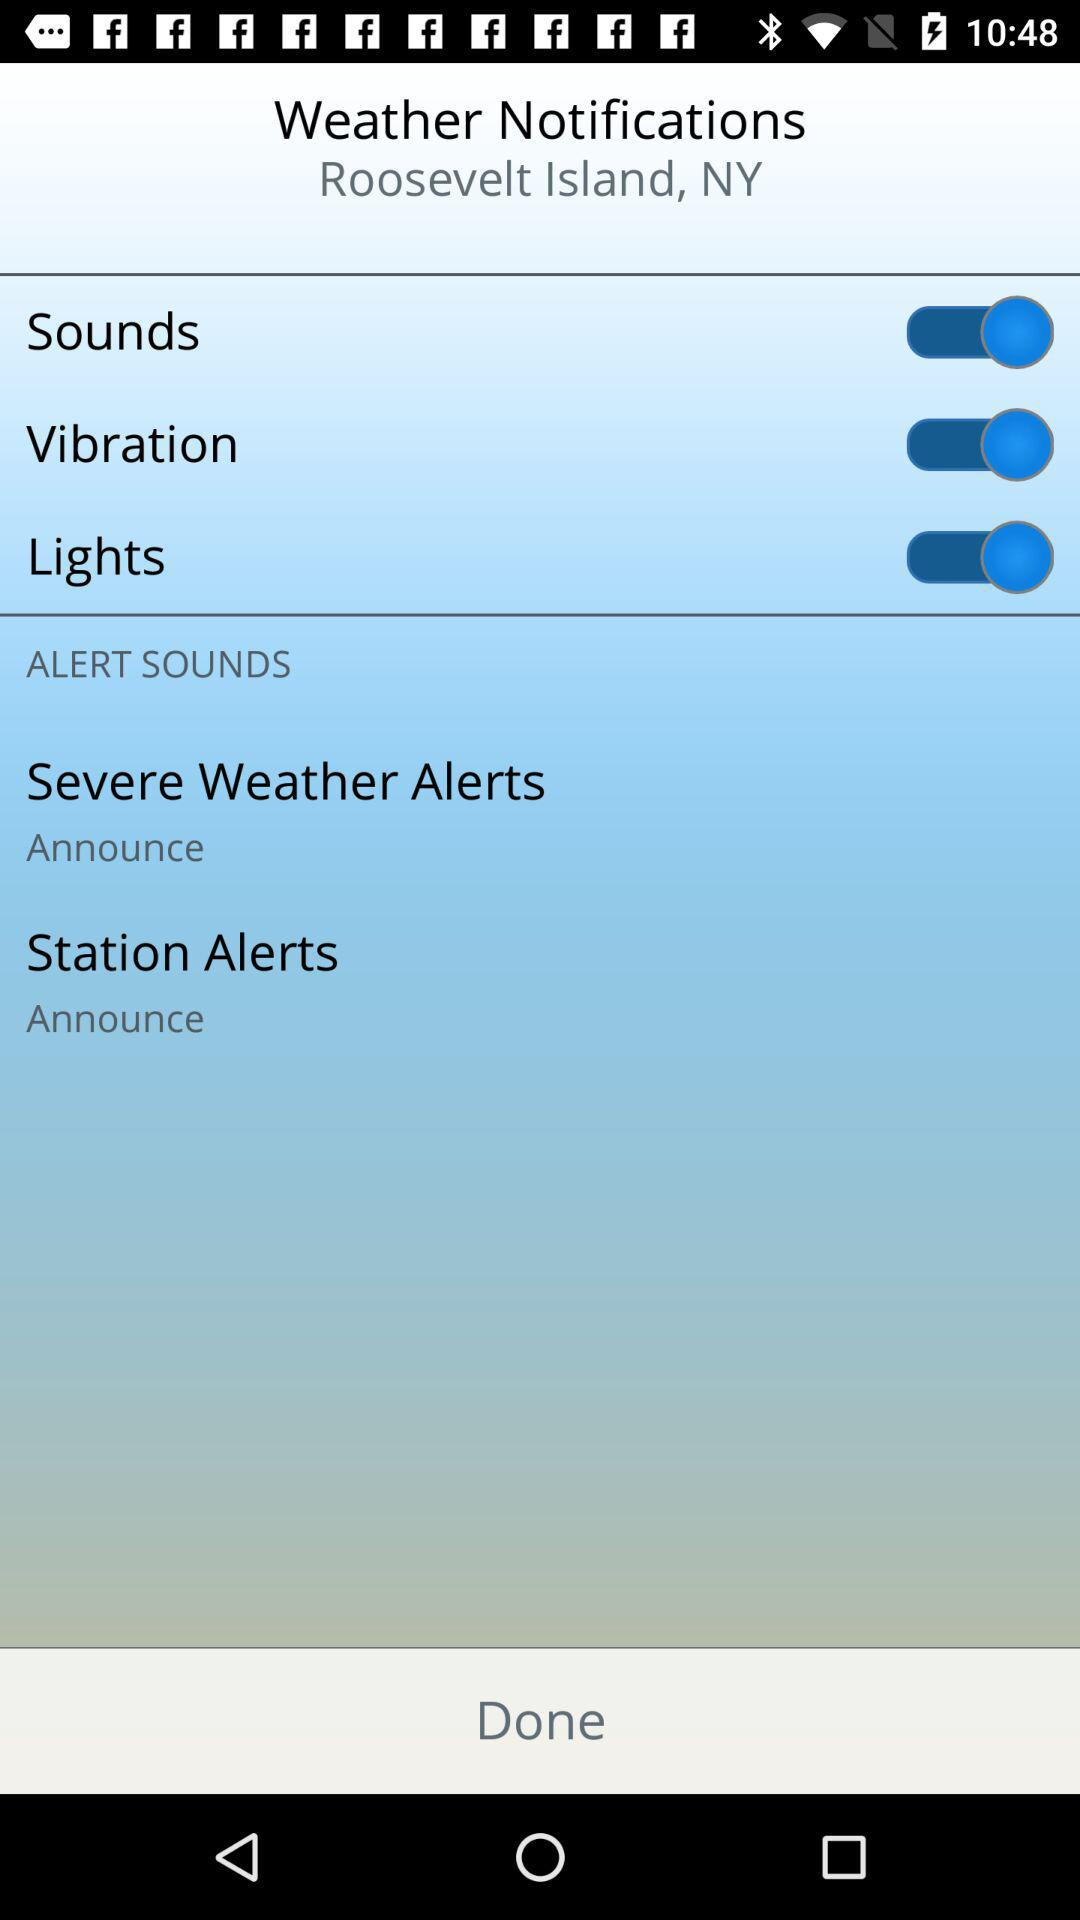How many alert sounds are there?
Answer the question using a single word or phrase. 2 